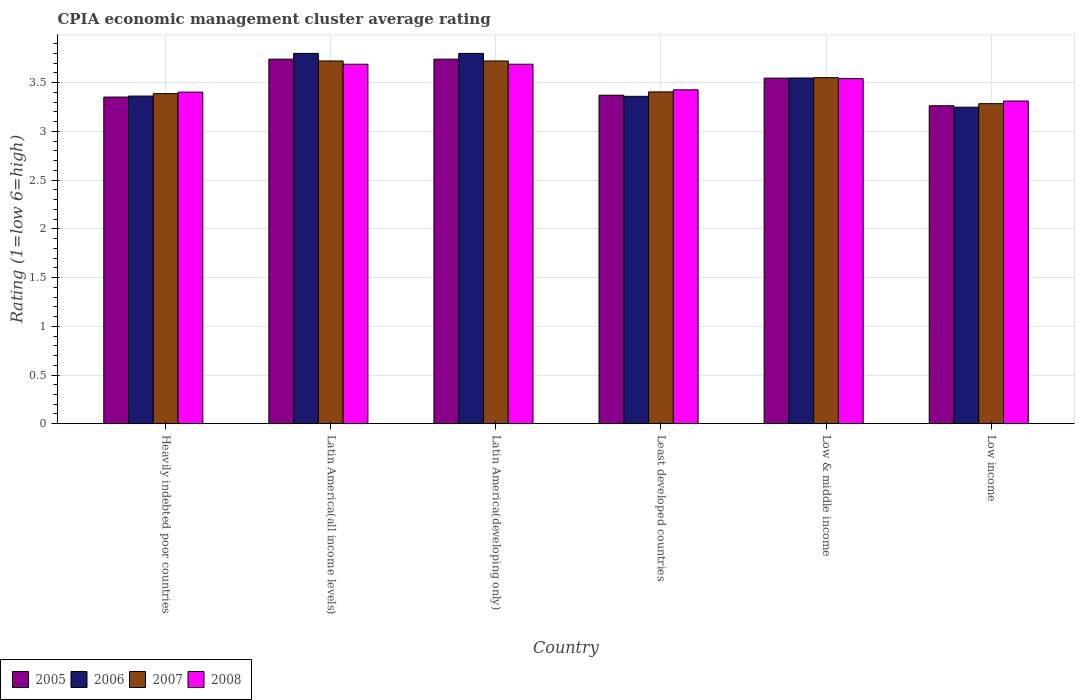Are the number of bars per tick equal to the number of legend labels?
Ensure brevity in your answer.  Yes. Are the number of bars on each tick of the X-axis equal?
Your answer should be compact. Yes. What is the label of the 6th group of bars from the left?
Keep it short and to the point. Low income. In how many cases, is the number of bars for a given country not equal to the number of legend labels?
Offer a terse response. 0. What is the CPIA rating in 2005 in Heavily indebted poor countries?
Provide a succinct answer. 3.35. Across all countries, what is the maximum CPIA rating in 2007?
Offer a terse response. 3.72. Across all countries, what is the minimum CPIA rating in 2005?
Offer a very short reply. 3.26. In which country was the CPIA rating in 2008 maximum?
Your answer should be very brief. Latin America(all income levels). In which country was the CPIA rating in 2008 minimum?
Provide a succinct answer. Low income. What is the total CPIA rating in 2005 in the graph?
Offer a terse response. 21.01. What is the difference between the CPIA rating in 2008 in Latin America(developing only) and that in Low & middle income?
Give a very brief answer. 0.15. What is the difference between the CPIA rating in 2006 in Low & middle income and the CPIA rating in 2007 in Low income?
Provide a short and direct response. 0.26. What is the average CPIA rating in 2006 per country?
Your answer should be very brief. 3.52. What is the difference between the CPIA rating of/in 2005 and CPIA rating of/in 2007 in Low & middle income?
Ensure brevity in your answer.  -0.01. What is the ratio of the CPIA rating in 2006 in Latin America(all income levels) to that in Low & middle income?
Your answer should be compact. 1.07. What is the difference between the highest and the second highest CPIA rating in 2006?
Give a very brief answer. -0.25. What is the difference between the highest and the lowest CPIA rating in 2008?
Your answer should be very brief. 0.38. Is the sum of the CPIA rating in 2008 in Heavily indebted poor countries and Low income greater than the maximum CPIA rating in 2007 across all countries?
Your answer should be compact. Yes. Is it the case that in every country, the sum of the CPIA rating in 2006 and CPIA rating in 2007 is greater than the sum of CPIA rating in 2008 and CPIA rating in 2005?
Provide a short and direct response. No. What does the 1st bar from the right in Heavily indebted poor countries represents?
Offer a very short reply. 2008. Is it the case that in every country, the sum of the CPIA rating in 2006 and CPIA rating in 2005 is greater than the CPIA rating in 2008?
Provide a succinct answer. Yes. Does the graph contain any zero values?
Make the answer very short. No. Where does the legend appear in the graph?
Make the answer very short. Bottom left. How many legend labels are there?
Make the answer very short. 4. How are the legend labels stacked?
Your answer should be compact. Horizontal. What is the title of the graph?
Offer a very short reply. CPIA economic management cluster average rating. Does "1990" appear as one of the legend labels in the graph?
Ensure brevity in your answer.  No. What is the label or title of the Y-axis?
Offer a very short reply. Rating (1=low 6=high). What is the Rating (1=low 6=high) of 2005 in Heavily indebted poor countries?
Your answer should be compact. 3.35. What is the Rating (1=low 6=high) of 2006 in Heavily indebted poor countries?
Provide a succinct answer. 3.36. What is the Rating (1=low 6=high) in 2007 in Heavily indebted poor countries?
Keep it short and to the point. 3.39. What is the Rating (1=low 6=high) of 2008 in Heavily indebted poor countries?
Your answer should be very brief. 3.4. What is the Rating (1=low 6=high) in 2005 in Latin America(all income levels)?
Make the answer very short. 3.74. What is the Rating (1=low 6=high) of 2006 in Latin America(all income levels)?
Offer a very short reply. 3.8. What is the Rating (1=low 6=high) of 2007 in Latin America(all income levels)?
Your response must be concise. 3.72. What is the Rating (1=low 6=high) in 2008 in Latin America(all income levels)?
Keep it short and to the point. 3.69. What is the Rating (1=low 6=high) in 2005 in Latin America(developing only)?
Offer a terse response. 3.74. What is the Rating (1=low 6=high) in 2007 in Latin America(developing only)?
Keep it short and to the point. 3.72. What is the Rating (1=low 6=high) in 2008 in Latin America(developing only)?
Your answer should be compact. 3.69. What is the Rating (1=low 6=high) in 2005 in Least developed countries?
Make the answer very short. 3.37. What is the Rating (1=low 6=high) in 2006 in Least developed countries?
Make the answer very short. 3.36. What is the Rating (1=low 6=high) of 2007 in Least developed countries?
Your answer should be compact. 3.4. What is the Rating (1=low 6=high) in 2008 in Least developed countries?
Ensure brevity in your answer.  3.43. What is the Rating (1=low 6=high) of 2005 in Low & middle income?
Keep it short and to the point. 3.55. What is the Rating (1=low 6=high) of 2006 in Low & middle income?
Provide a succinct answer. 3.55. What is the Rating (1=low 6=high) in 2007 in Low & middle income?
Keep it short and to the point. 3.55. What is the Rating (1=low 6=high) of 2008 in Low & middle income?
Offer a terse response. 3.54. What is the Rating (1=low 6=high) in 2005 in Low income?
Make the answer very short. 3.26. What is the Rating (1=low 6=high) in 2006 in Low income?
Ensure brevity in your answer.  3.25. What is the Rating (1=low 6=high) of 2007 in Low income?
Ensure brevity in your answer.  3.28. What is the Rating (1=low 6=high) in 2008 in Low income?
Offer a very short reply. 3.31. Across all countries, what is the maximum Rating (1=low 6=high) in 2005?
Ensure brevity in your answer.  3.74. Across all countries, what is the maximum Rating (1=low 6=high) of 2007?
Make the answer very short. 3.72. Across all countries, what is the maximum Rating (1=low 6=high) in 2008?
Offer a very short reply. 3.69. Across all countries, what is the minimum Rating (1=low 6=high) in 2005?
Provide a short and direct response. 3.26. Across all countries, what is the minimum Rating (1=low 6=high) in 2006?
Provide a succinct answer. 3.25. Across all countries, what is the minimum Rating (1=low 6=high) of 2007?
Offer a very short reply. 3.28. Across all countries, what is the minimum Rating (1=low 6=high) of 2008?
Provide a short and direct response. 3.31. What is the total Rating (1=low 6=high) in 2005 in the graph?
Give a very brief answer. 21.01. What is the total Rating (1=low 6=high) in 2006 in the graph?
Keep it short and to the point. 21.12. What is the total Rating (1=low 6=high) of 2007 in the graph?
Offer a very short reply. 21.07. What is the total Rating (1=low 6=high) in 2008 in the graph?
Offer a very short reply. 21.06. What is the difference between the Rating (1=low 6=high) of 2005 in Heavily indebted poor countries and that in Latin America(all income levels)?
Provide a short and direct response. -0.39. What is the difference between the Rating (1=low 6=high) of 2006 in Heavily indebted poor countries and that in Latin America(all income levels)?
Keep it short and to the point. -0.44. What is the difference between the Rating (1=low 6=high) in 2007 in Heavily indebted poor countries and that in Latin America(all income levels)?
Offer a terse response. -0.33. What is the difference between the Rating (1=low 6=high) of 2008 in Heavily indebted poor countries and that in Latin America(all income levels)?
Make the answer very short. -0.29. What is the difference between the Rating (1=low 6=high) in 2005 in Heavily indebted poor countries and that in Latin America(developing only)?
Your response must be concise. -0.39. What is the difference between the Rating (1=low 6=high) of 2006 in Heavily indebted poor countries and that in Latin America(developing only)?
Your answer should be compact. -0.44. What is the difference between the Rating (1=low 6=high) in 2007 in Heavily indebted poor countries and that in Latin America(developing only)?
Your response must be concise. -0.33. What is the difference between the Rating (1=low 6=high) of 2008 in Heavily indebted poor countries and that in Latin America(developing only)?
Provide a short and direct response. -0.29. What is the difference between the Rating (1=low 6=high) of 2005 in Heavily indebted poor countries and that in Least developed countries?
Offer a terse response. -0.02. What is the difference between the Rating (1=low 6=high) in 2006 in Heavily indebted poor countries and that in Least developed countries?
Your answer should be very brief. 0. What is the difference between the Rating (1=low 6=high) in 2007 in Heavily indebted poor countries and that in Least developed countries?
Give a very brief answer. -0.02. What is the difference between the Rating (1=low 6=high) in 2008 in Heavily indebted poor countries and that in Least developed countries?
Keep it short and to the point. -0.02. What is the difference between the Rating (1=low 6=high) in 2005 in Heavily indebted poor countries and that in Low & middle income?
Your response must be concise. -0.19. What is the difference between the Rating (1=low 6=high) of 2006 in Heavily indebted poor countries and that in Low & middle income?
Provide a short and direct response. -0.19. What is the difference between the Rating (1=low 6=high) in 2007 in Heavily indebted poor countries and that in Low & middle income?
Your answer should be very brief. -0.16. What is the difference between the Rating (1=low 6=high) in 2008 in Heavily indebted poor countries and that in Low & middle income?
Your answer should be compact. -0.14. What is the difference between the Rating (1=low 6=high) of 2005 in Heavily indebted poor countries and that in Low income?
Offer a very short reply. 0.09. What is the difference between the Rating (1=low 6=high) of 2006 in Heavily indebted poor countries and that in Low income?
Offer a very short reply. 0.11. What is the difference between the Rating (1=low 6=high) in 2007 in Heavily indebted poor countries and that in Low income?
Your answer should be compact. 0.1. What is the difference between the Rating (1=low 6=high) in 2008 in Heavily indebted poor countries and that in Low income?
Offer a terse response. 0.09. What is the difference between the Rating (1=low 6=high) in 2006 in Latin America(all income levels) and that in Latin America(developing only)?
Ensure brevity in your answer.  0. What is the difference between the Rating (1=low 6=high) of 2007 in Latin America(all income levels) and that in Latin America(developing only)?
Offer a very short reply. 0. What is the difference between the Rating (1=low 6=high) in 2008 in Latin America(all income levels) and that in Latin America(developing only)?
Provide a short and direct response. 0. What is the difference between the Rating (1=low 6=high) of 2005 in Latin America(all income levels) and that in Least developed countries?
Your response must be concise. 0.37. What is the difference between the Rating (1=low 6=high) of 2006 in Latin America(all income levels) and that in Least developed countries?
Offer a very short reply. 0.44. What is the difference between the Rating (1=low 6=high) in 2007 in Latin America(all income levels) and that in Least developed countries?
Make the answer very short. 0.32. What is the difference between the Rating (1=low 6=high) in 2008 in Latin America(all income levels) and that in Least developed countries?
Your answer should be very brief. 0.26. What is the difference between the Rating (1=low 6=high) of 2005 in Latin America(all income levels) and that in Low & middle income?
Your answer should be very brief. 0.19. What is the difference between the Rating (1=low 6=high) in 2006 in Latin America(all income levels) and that in Low & middle income?
Give a very brief answer. 0.25. What is the difference between the Rating (1=low 6=high) of 2007 in Latin America(all income levels) and that in Low & middle income?
Ensure brevity in your answer.  0.17. What is the difference between the Rating (1=low 6=high) of 2008 in Latin America(all income levels) and that in Low & middle income?
Your answer should be compact. 0.15. What is the difference between the Rating (1=low 6=high) of 2005 in Latin America(all income levels) and that in Low income?
Offer a very short reply. 0.48. What is the difference between the Rating (1=low 6=high) of 2006 in Latin America(all income levels) and that in Low income?
Give a very brief answer. 0.55. What is the difference between the Rating (1=low 6=high) of 2007 in Latin America(all income levels) and that in Low income?
Offer a terse response. 0.44. What is the difference between the Rating (1=low 6=high) in 2008 in Latin America(all income levels) and that in Low income?
Make the answer very short. 0.38. What is the difference between the Rating (1=low 6=high) of 2005 in Latin America(developing only) and that in Least developed countries?
Offer a terse response. 0.37. What is the difference between the Rating (1=low 6=high) in 2006 in Latin America(developing only) and that in Least developed countries?
Ensure brevity in your answer.  0.44. What is the difference between the Rating (1=low 6=high) of 2007 in Latin America(developing only) and that in Least developed countries?
Offer a terse response. 0.32. What is the difference between the Rating (1=low 6=high) in 2008 in Latin America(developing only) and that in Least developed countries?
Offer a terse response. 0.26. What is the difference between the Rating (1=low 6=high) of 2005 in Latin America(developing only) and that in Low & middle income?
Your answer should be compact. 0.19. What is the difference between the Rating (1=low 6=high) in 2006 in Latin America(developing only) and that in Low & middle income?
Offer a terse response. 0.25. What is the difference between the Rating (1=low 6=high) in 2007 in Latin America(developing only) and that in Low & middle income?
Provide a succinct answer. 0.17. What is the difference between the Rating (1=low 6=high) of 2008 in Latin America(developing only) and that in Low & middle income?
Your answer should be very brief. 0.15. What is the difference between the Rating (1=low 6=high) of 2005 in Latin America(developing only) and that in Low income?
Give a very brief answer. 0.48. What is the difference between the Rating (1=low 6=high) in 2006 in Latin America(developing only) and that in Low income?
Keep it short and to the point. 0.55. What is the difference between the Rating (1=low 6=high) in 2007 in Latin America(developing only) and that in Low income?
Keep it short and to the point. 0.44. What is the difference between the Rating (1=low 6=high) in 2008 in Latin America(developing only) and that in Low income?
Make the answer very short. 0.38. What is the difference between the Rating (1=low 6=high) in 2005 in Least developed countries and that in Low & middle income?
Provide a short and direct response. -0.18. What is the difference between the Rating (1=low 6=high) in 2006 in Least developed countries and that in Low & middle income?
Give a very brief answer. -0.19. What is the difference between the Rating (1=low 6=high) of 2007 in Least developed countries and that in Low & middle income?
Provide a succinct answer. -0.15. What is the difference between the Rating (1=low 6=high) of 2008 in Least developed countries and that in Low & middle income?
Provide a short and direct response. -0.12. What is the difference between the Rating (1=low 6=high) of 2005 in Least developed countries and that in Low income?
Give a very brief answer. 0.11. What is the difference between the Rating (1=low 6=high) of 2006 in Least developed countries and that in Low income?
Make the answer very short. 0.11. What is the difference between the Rating (1=low 6=high) of 2007 in Least developed countries and that in Low income?
Your response must be concise. 0.12. What is the difference between the Rating (1=low 6=high) of 2008 in Least developed countries and that in Low income?
Ensure brevity in your answer.  0.12. What is the difference between the Rating (1=low 6=high) of 2005 in Low & middle income and that in Low income?
Give a very brief answer. 0.28. What is the difference between the Rating (1=low 6=high) of 2006 in Low & middle income and that in Low income?
Keep it short and to the point. 0.3. What is the difference between the Rating (1=low 6=high) of 2007 in Low & middle income and that in Low income?
Make the answer very short. 0.27. What is the difference between the Rating (1=low 6=high) of 2008 in Low & middle income and that in Low income?
Offer a very short reply. 0.23. What is the difference between the Rating (1=low 6=high) of 2005 in Heavily indebted poor countries and the Rating (1=low 6=high) of 2006 in Latin America(all income levels)?
Provide a short and direct response. -0.45. What is the difference between the Rating (1=low 6=high) of 2005 in Heavily indebted poor countries and the Rating (1=low 6=high) of 2007 in Latin America(all income levels)?
Your response must be concise. -0.37. What is the difference between the Rating (1=low 6=high) in 2005 in Heavily indebted poor countries and the Rating (1=low 6=high) in 2008 in Latin America(all income levels)?
Your answer should be very brief. -0.34. What is the difference between the Rating (1=low 6=high) in 2006 in Heavily indebted poor countries and the Rating (1=low 6=high) in 2007 in Latin America(all income levels)?
Your response must be concise. -0.36. What is the difference between the Rating (1=low 6=high) of 2006 in Heavily indebted poor countries and the Rating (1=low 6=high) of 2008 in Latin America(all income levels)?
Make the answer very short. -0.33. What is the difference between the Rating (1=low 6=high) of 2007 in Heavily indebted poor countries and the Rating (1=low 6=high) of 2008 in Latin America(all income levels)?
Provide a short and direct response. -0.3. What is the difference between the Rating (1=low 6=high) of 2005 in Heavily indebted poor countries and the Rating (1=low 6=high) of 2006 in Latin America(developing only)?
Provide a succinct answer. -0.45. What is the difference between the Rating (1=low 6=high) of 2005 in Heavily indebted poor countries and the Rating (1=low 6=high) of 2007 in Latin America(developing only)?
Your answer should be very brief. -0.37. What is the difference between the Rating (1=low 6=high) in 2005 in Heavily indebted poor countries and the Rating (1=low 6=high) in 2008 in Latin America(developing only)?
Offer a very short reply. -0.34. What is the difference between the Rating (1=low 6=high) of 2006 in Heavily indebted poor countries and the Rating (1=low 6=high) of 2007 in Latin America(developing only)?
Keep it short and to the point. -0.36. What is the difference between the Rating (1=low 6=high) in 2006 in Heavily indebted poor countries and the Rating (1=low 6=high) in 2008 in Latin America(developing only)?
Give a very brief answer. -0.33. What is the difference between the Rating (1=low 6=high) of 2007 in Heavily indebted poor countries and the Rating (1=low 6=high) of 2008 in Latin America(developing only)?
Provide a succinct answer. -0.3. What is the difference between the Rating (1=low 6=high) of 2005 in Heavily indebted poor countries and the Rating (1=low 6=high) of 2006 in Least developed countries?
Ensure brevity in your answer.  -0.01. What is the difference between the Rating (1=low 6=high) of 2005 in Heavily indebted poor countries and the Rating (1=low 6=high) of 2007 in Least developed countries?
Offer a very short reply. -0.05. What is the difference between the Rating (1=low 6=high) of 2005 in Heavily indebted poor countries and the Rating (1=low 6=high) of 2008 in Least developed countries?
Your response must be concise. -0.07. What is the difference between the Rating (1=low 6=high) of 2006 in Heavily indebted poor countries and the Rating (1=low 6=high) of 2007 in Least developed countries?
Your answer should be compact. -0.04. What is the difference between the Rating (1=low 6=high) of 2006 in Heavily indebted poor countries and the Rating (1=low 6=high) of 2008 in Least developed countries?
Offer a terse response. -0.06. What is the difference between the Rating (1=low 6=high) of 2007 in Heavily indebted poor countries and the Rating (1=low 6=high) of 2008 in Least developed countries?
Your answer should be very brief. -0.04. What is the difference between the Rating (1=low 6=high) of 2005 in Heavily indebted poor countries and the Rating (1=low 6=high) of 2006 in Low & middle income?
Give a very brief answer. -0.2. What is the difference between the Rating (1=low 6=high) in 2005 in Heavily indebted poor countries and the Rating (1=low 6=high) in 2007 in Low & middle income?
Offer a terse response. -0.2. What is the difference between the Rating (1=low 6=high) in 2005 in Heavily indebted poor countries and the Rating (1=low 6=high) in 2008 in Low & middle income?
Offer a terse response. -0.19. What is the difference between the Rating (1=low 6=high) of 2006 in Heavily indebted poor countries and the Rating (1=low 6=high) of 2007 in Low & middle income?
Make the answer very short. -0.19. What is the difference between the Rating (1=low 6=high) of 2006 in Heavily indebted poor countries and the Rating (1=low 6=high) of 2008 in Low & middle income?
Your response must be concise. -0.18. What is the difference between the Rating (1=low 6=high) in 2007 in Heavily indebted poor countries and the Rating (1=low 6=high) in 2008 in Low & middle income?
Offer a very short reply. -0.15. What is the difference between the Rating (1=low 6=high) of 2005 in Heavily indebted poor countries and the Rating (1=low 6=high) of 2006 in Low income?
Keep it short and to the point. 0.1. What is the difference between the Rating (1=low 6=high) of 2005 in Heavily indebted poor countries and the Rating (1=low 6=high) of 2007 in Low income?
Ensure brevity in your answer.  0.07. What is the difference between the Rating (1=low 6=high) of 2005 in Heavily indebted poor countries and the Rating (1=low 6=high) of 2008 in Low income?
Provide a short and direct response. 0.04. What is the difference between the Rating (1=low 6=high) of 2006 in Heavily indebted poor countries and the Rating (1=low 6=high) of 2007 in Low income?
Offer a very short reply. 0.08. What is the difference between the Rating (1=low 6=high) of 2006 in Heavily indebted poor countries and the Rating (1=low 6=high) of 2008 in Low income?
Your answer should be compact. 0.05. What is the difference between the Rating (1=low 6=high) of 2007 in Heavily indebted poor countries and the Rating (1=low 6=high) of 2008 in Low income?
Offer a very short reply. 0.08. What is the difference between the Rating (1=low 6=high) in 2005 in Latin America(all income levels) and the Rating (1=low 6=high) in 2006 in Latin America(developing only)?
Make the answer very short. -0.06. What is the difference between the Rating (1=low 6=high) of 2005 in Latin America(all income levels) and the Rating (1=low 6=high) of 2007 in Latin America(developing only)?
Give a very brief answer. 0.02. What is the difference between the Rating (1=low 6=high) of 2005 in Latin America(all income levels) and the Rating (1=low 6=high) of 2008 in Latin America(developing only)?
Offer a terse response. 0.05. What is the difference between the Rating (1=low 6=high) in 2006 in Latin America(all income levels) and the Rating (1=low 6=high) in 2007 in Latin America(developing only)?
Your answer should be compact. 0.08. What is the difference between the Rating (1=low 6=high) in 2007 in Latin America(all income levels) and the Rating (1=low 6=high) in 2008 in Latin America(developing only)?
Your answer should be very brief. 0.03. What is the difference between the Rating (1=low 6=high) of 2005 in Latin America(all income levels) and the Rating (1=low 6=high) of 2006 in Least developed countries?
Give a very brief answer. 0.38. What is the difference between the Rating (1=low 6=high) in 2005 in Latin America(all income levels) and the Rating (1=low 6=high) in 2007 in Least developed countries?
Give a very brief answer. 0.34. What is the difference between the Rating (1=low 6=high) in 2005 in Latin America(all income levels) and the Rating (1=low 6=high) in 2008 in Least developed countries?
Your answer should be compact. 0.31. What is the difference between the Rating (1=low 6=high) in 2006 in Latin America(all income levels) and the Rating (1=low 6=high) in 2007 in Least developed countries?
Provide a succinct answer. 0.4. What is the difference between the Rating (1=low 6=high) of 2006 in Latin America(all income levels) and the Rating (1=low 6=high) of 2008 in Least developed countries?
Ensure brevity in your answer.  0.37. What is the difference between the Rating (1=low 6=high) of 2007 in Latin America(all income levels) and the Rating (1=low 6=high) of 2008 in Least developed countries?
Provide a short and direct response. 0.3. What is the difference between the Rating (1=low 6=high) in 2005 in Latin America(all income levels) and the Rating (1=low 6=high) in 2006 in Low & middle income?
Offer a terse response. 0.19. What is the difference between the Rating (1=low 6=high) of 2005 in Latin America(all income levels) and the Rating (1=low 6=high) of 2007 in Low & middle income?
Keep it short and to the point. 0.19. What is the difference between the Rating (1=low 6=high) in 2005 in Latin America(all income levels) and the Rating (1=low 6=high) in 2008 in Low & middle income?
Offer a terse response. 0.2. What is the difference between the Rating (1=low 6=high) in 2006 in Latin America(all income levels) and the Rating (1=low 6=high) in 2007 in Low & middle income?
Provide a succinct answer. 0.25. What is the difference between the Rating (1=low 6=high) of 2006 in Latin America(all income levels) and the Rating (1=low 6=high) of 2008 in Low & middle income?
Give a very brief answer. 0.26. What is the difference between the Rating (1=low 6=high) of 2007 in Latin America(all income levels) and the Rating (1=low 6=high) of 2008 in Low & middle income?
Ensure brevity in your answer.  0.18. What is the difference between the Rating (1=low 6=high) of 2005 in Latin America(all income levels) and the Rating (1=low 6=high) of 2006 in Low income?
Your answer should be very brief. 0.49. What is the difference between the Rating (1=low 6=high) of 2005 in Latin America(all income levels) and the Rating (1=low 6=high) of 2007 in Low income?
Offer a terse response. 0.46. What is the difference between the Rating (1=low 6=high) in 2005 in Latin America(all income levels) and the Rating (1=low 6=high) in 2008 in Low income?
Your answer should be compact. 0.43. What is the difference between the Rating (1=low 6=high) of 2006 in Latin America(all income levels) and the Rating (1=low 6=high) of 2007 in Low income?
Provide a short and direct response. 0.52. What is the difference between the Rating (1=low 6=high) of 2006 in Latin America(all income levels) and the Rating (1=low 6=high) of 2008 in Low income?
Make the answer very short. 0.49. What is the difference between the Rating (1=low 6=high) in 2007 in Latin America(all income levels) and the Rating (1=low 6=high) in 2008 in Low income?
Give a very brief answer. 0.41. What is the difference between the Rating (1=low 6=high) in 2005 in Latin America(developing only) and the Rating (1=low 6=high) in 2006 in Least developed countries?
Offer a very short reply. 0.38. What is the difference between the Rating (1=low 6=high) of 2005 in Latin America(developing only) and the Rating (1=low 6=high) of 2007 in Least developed countries?
Provide a short and direct response. 0.34. What is the difference between the Rating (1=low 6=high) in 2005 in Latin America(developing only) and the Rating (1=low 6=high) in 2008 in Least developed countries?
Offer a very short reply. 0.31. What is the difference between the Rating (1=low 6=high) in 2006 in Latin America(developing only) and the Rating (1=low 6=high) in 2007 in Least developed countries?
Provide a short and direct response. 0.4. What is the difference between the Rating (1=low 6=high) of 2006 in Latin America(developing only) and the Rating (1=low 6=high) of 2008 in Least developed countries?
Keep it short and to the point. 0.37. What is the difference between the Rating (1=low 6=high) in 2007 in Latin America(developing only) and the Rating (1=low 6=high) in 2008 in Least developed countries?
Make the answer very short. 0.3. What is the difference between the Rating (1=low 6=high) of 2005 in Latin America(developing only) and the Rating (1=low 6=high) of 2006 in Low & middle income?
Your answer should be very brief. 0.19. What is the difference between the Rating (1=low 6=high) in 2005 in Latin America(developing only) and the Rating (1=low 6=high) in 2007 in Low & middle income?
Make the answer very short. 0.19. What is the difference between the Rating (1=low 6=high) of 2005 in Latin America(developing only) and the Rating (1=low 6=high) of 2008 in Low & middle income?
Ensure brevity in your answer.  0.2. What is the difference between the Rating (1=low 6=high) of 2006 in Latin America(developing only) and the Rating (1=low 6=high) of 2007 in Low & middle income?
Make the answer very short. 0.25. What is the difference between the Rating (1=low 6=high) in 2006 in Latin America(developing only) and the Rating (1=low 6=high) in 2008 in Low & middle income?
Give a very brief answer. 0.26. What is the difference between the Rating (1=low 6=high) in 2007 in Latin America(developing only) and the Rating (1=low 6=high) in 2008 in Low & middle income?
Your response must be concise. 0.18. What is the difference between the Rating (1=low 6=high) of 2005 in Latin America(developing only) and the Rating (1=low 6=high) of 2006 in Low income?
Provide a short and direct response. 0.49. What is the difference between the Rating (1=low 6=high) of 2005 in Latin America(developing only) and the Rating (1=low 6=high) of 2007 in Low income?
Your answer should be very brief. 0.46. What is the difference between the Rating (1=low 6=high) of 2005 in Latin America(developing only) and the Rating (1=low 6=high) of 2008 in Low income?
Offer a very short reply. 0.43. What is the difference between the Rating (1=low 6=high) of 2006 in Latin America(developing only) and the Rating (1=low 6=high) of 2007 in Low income?
Make the answer very short. 0.52. What is the difference between the Rating (1=low 6=high) in 2006 in Latin America(developing only) and the Rating (1=low 6=high) in 2008 in Low income?
Offer a terse response. 0.49. What is the difference between the Rating (1=low 6=high) of 2007 in Latin America(developing only) and the Rating (1=low 6=high) of 2008 in Low income?
Your answer should be compact. 0.41. What is the difference between the Rating (1=low 6=high) of 2005 in Least developed countries and the Rating (1=low 6=high) of 2006 in Low & middle income?
Your answer should be compact. -0.18. What is the difference between the Rating (1=low 6=high) in 2005 in Least developed countries and the Rating (1=low 6=high) in 2007 in Low & middle income?
Your answer should be compact. -0.18. What is the difference between the Rating (1=low 6=high) of 2005 in Least developed countries and the Rating (1=low 6=high) of 2008 in Low & middle income?
Keep it short and to the point. -0.17. What is the difference between the Rating (1=low 6=high) in 2006 in Least developed countries and the Rating (1=low 6=high) in 2007 in Low & middle income?
Make the answer very short. -0.19. What is the difference between the Rating (1=low 6=high) in 2006 in Least developed countries and the Rating (1=low 6=high) in 2008 in Low & middle income?
Give a very brief answer. -0.18. What is the difference between the Rating (1=low 6=high) in 2007 in Least developed countries and the Rating (1=low 6=high) in 2008 in Low & middle income?
Offer a very short reply. -0.14. What is the difference between the Rating (1=low 6=high) of 2005 in Least developed countries and the Rating (1=low 6=high) of 2006 in Low income?
Make the answer very short. 0.12. What is the difference between the Rating (1=low 6=high) of 2005 in Least developed countries and the Rating (1=low 6=high) of 2007 in Low income?
Provide a succinct answer. 0.09. What is the difference between the Rating (1=low 6=high) in 2005 in Least developed countries and the Rating (1=low 6=high) in 2008 in Low income?
Provide a succinct answer. 0.06. What is the difference between the Rating (1=low 6=high) in 2006 in Least developed countries and the Rating (1=low 6=high) in 2007 in Low income?
Keep it short and to the point. 0.08. What is the difference between the Rating (1=low 6=high) of 2006 in Least developed countries and the Rating (1=low 6=high) of 2008 in Low income?
Your answer should be very brief. 0.05. What is the difference between the Rating (1=low 6=high) in 2007 in Least developed countries and the Rating (1=low 6=high) in 2008 in Low income?
Your answer should be very brief. 0.09. What is the difference between the Rating (1=low 6=high) of 2005 in Low & middle income and the Rating (1=low 6=high) of 2006 in Low income?
Keep it short and to the point. 0.3. What is the difference between the Rating (1=low 6=high) of 2005 in Low & middle income and the Rating (1=low 6=high) of 2007 in Low income?
Give a very brief answer. 0.26. What is the difference between the Rating (1=low 6=high) in 2005 in Low & middle income and the Rating (1=low 6=high) in 2008 in Low income?
Offer a terse response. 0.23. What is the difference between the Rating (1=low 6=high) of 2006 in Low & middle income and the Rating (1=low 6=high) of 2007 in Low income?
Make the answer very short. 0.26. What is the difference between the Rating (1=low 6=high) in 2006 in Low & middle income and the Rating (1=low 6=high) in 2008 in Low income?
Provide a succinct answer. 0.24. What is the difference between the Rating (1=low 6=high) of 2007 in Low & middle income and the Rating (1=low 6=high) of 2008 in Low income?
Make the answer very short. 0.24. What is the average Rating (1=low 6=high) in 2005 per country?
Give a very brief answer. 3.5. What is the average Rating (1=low 6=high) in 2006 per country?
Provide a succinct answer. 3.52. What is the average Rating (1=low 6=high) in 2007 per country?
Offer a very short reply. 3.51. What is the average Rating (1=low 6=high) in 2008 per country?
Keep it short and to the point. 3.51. What is the difference between the Rating (1=low 6=high) in 2005 and Rating (1=low 6=high) in 2006 in Heavily indebted poor countries?
Give a very brief answer. -0.01. What is the difference between the Rating (1=low 6=high) in 2005 and Rating (1=low 6=high) in 2007 in Heavily indebted poor countries?
Keep it short and to the point. -0.04. What is the difference between the Rating (1=low 6=high) of 2005 and Rating (1=low 6=high) of 2008 in Heavily indebted poor countries?
Provide a succinct answer. -0.05. What is the difference between the Rating (1=low 6=high) in 2006 and Rating (1=low 6=high) in 2007 in Heavily indebted poor countries?
Give a very brief answer. -0.03. What is the difference between the Rating (1=low 6=high) in 2006 and Rating (1=low 6=high) in 2008 in Heavily indebted poor countries?
Make the answer very short. -0.04. What is the difference between the Rating (1=low 6=high) in 2007 and Rating (1=low 6=high) in 2008 in Heavily indebted poor countries?
Your answer should be compact. -0.02. What is the difference between the Rating (1=low 6=high) of 2005 and Rating (1=low 6=high) of 2006 in Latin America(all income levels)?
Make the answer very short. -0.06. What is the difference between the Rating (1=low 6=high) in 2005 and Rating (1=low 6=high) in 2007 in Latin America(all income levels)?
Offer a terse response. 0.02. What is the difference between the Rating (1=low 6=high) of 2005 and Rating (1=low 6=high) of 2008 in Latin America(all income levels)?
Offer a terse response. 0.05. What is the difference between the Rating (1=low 6=high) of 2006 and Rating (1=low 6=high) of 2007 in Latin America(all income levels)?
Give a very brief answer. 0.08. What is the difference between the Rating (1=low 6=high) of 2006 and Rating (1=low 6=high) of 2008 in Latin America(all income levels)?
Keep it short and to the point. 0.11. What is the difference between the Rating (1=low 6=high) in 2005 and Rating (1=low 6=high) in 2006 in Latin America(developing only)?
Provide a succinct answer. -0.06. What is the difference between the Rating (1=low 6=high) of 2005 and Rating (1=low 6=high) of 2007 in Latin America(developing only)?
Offer a very short reply. 0.02. What is the difference between the Rating (1=low 6=high) of 2005 and Rating (1=low 6=high) of 2008 in Latin America(developing only)?
Keep it short and to the point. 0.05. What is the difference between the Rating (1=low 6=high) in 2006 and Rating (1=low 6=high) in 2007 in Latin America(developing only)?
Your answer should be very brief. 0.08. What is the difference between the Rating (1=low 6=high) in 2006 and Rating (1=low 6=high) in 2008 in Latin America(developing only)?
Make the answer very short. 0.11. What is the difference between the Rating (1=low 6=high) of 2007 and Rating (1=low 6=high) of 2008 in Latin America(developing only)?
Your response must be concise. 0.03. What is the difference between the Rating (1=low 6=high) of 2005 and Rating (1=low 6=high) of 2006 in Least developed countries?
Give a very brief answer. 0.01. What is the difference between the Rating (1=low 6=high) in 2005 and Rating (1=low 6=high) in 2007 in Least developed countries?
Your answer should be compact. -0.03. What is the difference between the Rating (1=low 6=high) in 2005 and Rating (1=low 6=high) in 2008 in Least developed countries?
Your response must be concise. -0.06. What is the difference between the Rating (1=low 6=high) of 2006 and Rating (1=low 6=high) of 2007 in Least developed countries?
Your answer should be very brief. -0.05. What is the difference between the Rating (1=low 6=high) in 2006 and Rating (1=low 6=high) in 2008 in Least developed countries?
Keep it short and to the point. -0.07. What is the difference between the Rating (1=low 6=high) in 2007 and Rating (1=low 6=high) in 2008 in Least developed countries?
Ensure brevity in your answer.  -0.02. What is the difference between the Rating (1=low 6=high) in 2005 and Rating (1=low 6=high) in 2006 in Low & middle income?
Your response must be concise. -0. What is the difference between the Rating (1=low 6=high) in 2005 and Rating (1=low 6=high) in 2007 in Low & middle income?
Offer a very short reply. -0.01. What is the difference between the Rating (1=low 6=high) in 2005 and Rating (1=low 6=high) in 2008 in Low & middle income?
Ensure brevity in your answer.  0. What is the difference between the Rating (1=low 6=high) in 2006 and Rating (1=low 6=high) in 2007 in Low & middle income?
Your answer should be compact. -0. What is the difference between the Rating (1=low 6=high) of 2006 and Rating (1=low 6=high) of 2008 in Low & middle income?
Your answer should be very brief. 0.01. What is the difference between the Rating (1=low 6=high) in 2007 and Rating (1=low 6=high) in 2008 in Low & middle income?
Give a very brief answer. 0.01. What is the difference between the Rating (1=low 6=high) of 2005 and Rating (1=low 6=high) of 2006 in Low income?
Offer a terse response. 0.01. What is the difference between the Rating (1=low 6=high) in 2005 and Rating (1=low 6=high) in 2007 in Low income?
Provide a short and direct response. -0.02. What is the difference between the Rating (1=low 6=high) of 2005 and Rating (1=low 6=high) of 2008 in Low income?
Keep it short and to the point. -0.05. What is the difference between the Rating (1=low 6=high) of 2006 and Rating (1=low 6=high) of 2007 in Low income?
Provide a short and direct response. -0.04. What is the difference between the Rating (1=low 6=high) of 2006 and Rating (1=low 6=high) of 2008 in Low income?
Your response must be concise. -0.06. What is the difference between the Rating (1=low 6=high) of 2007 and Rating (1=low 6=high) of 2008 in Low income?
Make the answer very short. -0.03. What is the ratio of the Rating (1=low 6=high) of 2005 in Heavily indebted poor countries to that in Latin America(all income levels)?
Give a very brief answer. 0.9. What is the ratio of the Rating (1=low 6=high) in 2006 in Heavily indebted poor countries to that in Latin America(all income levels)?
Offer a very short reply. 0.88. What is the ratio of the Rating (1=low 6=high) of 2007 in Heavily indebted poor countries to that in Latin America(all income levels)?
Offer a very short reply. 0.91. What is the ratio of the Rating (1=low 6=high) of 2008 in Heavily indebted poor countries to that in Latin America(all income levels)?
Offer a very short reply. 0.92. What is the ratio of the Rating (1=low 6=high) of 2005 in Heavily indebted poor countries to that in Latin America(developing only)?
Your answer should be very brief. 0.9. What is the ratio of the Rating (1=low 6=high) in 2006 in Heavily indebted poor countries to that in Latin America(developing only)?
Offer a very short reply. 0.88. What is the ratio of the Rating (1=low 6=high) in 2007 in Heavily indebted poor countries to that in Latin America(developing only)?
Offer a terse response. 0.91. What is the ratio of the Rating (1=low 6=high) in 2008 in Heavily indebted poor countries to that in Latin America(developing only)?
Make the answer very short. 0.92. What is the ratio of the Rating (1=low 6=high) in 2008 in Heavily indebted poor countries to that in Least developed countries?
Ensure brevity in your answer.  0.99. What is the ratio of the Rating (1=low 6=high) in 2005 in Heavily indebted poor countries to that in Low & middle income?
Make the answer very short. 0.95. What is the ratio of the Rating (1=low 6=high) of 2006 in Heavily indebted poor countries to that in Low & middle income?
Offer a terse response. 0.95. What is the ratio of the Rating (1=low 6=high) of 2007 in Heavily indebted poor countries to that in Low & middle income?
Your answer should be very brief. 0.95. What is the ratio of the Rating (1=low 6=high) in 2008 in Heavily indebted poor countries to that in Low & middle income?
Make the answer very short. 0.96. What is the ratio of the Rating (1=low 6=high) in 2005 in Heavily indebted poor countries to that in Low income?
Provide a short and direct response. 1.03. What is the ratio of the Rating (1=low 6=high) of 2006 in Heavily indebted poor countries to that in Low income?
Your answer should be very brief. 1.04. What is the ratio of the Rating (1=low 6=high) in 2007 in Heavily indebted poor countries to that in Low income?
Your response must be concise. 1.03. What is the ratio of the Rating (1=low 6=high) in 2008 in Heavily indebted poor countries to that in Low income?
Offer a terse response. 1.03. What is the ratio of the Rating (1=low 6=high) of 2007 in Latin America(all income levels) to that in Latin America(developing only)?
Your response must be concise. 1. What is the ratio of the Rating (1=low 6=high) in 2008 in Latin America(all income levels) to that in Latin America(developing only)?
Provide a succinct answer. 1. What is the ratio of the Rating (1=low 6=high) in 2005 in Latin America(all income levels) to that in Least developed countries?
Keep it short and to the point. 1.11. What is the ratio of the Rating (1=low 6=high) of 2006 in Latin America(all income levels) to that in Least developed countries?
Make the answer very short. 1.13. What is the ratio of the Rating (1=low 6=high) in 2007 in Latin America(all income levels) to that in Least developed countries?
Give a very brief answer. 1.09. What is the ratio of the Rating (1=low 6=high) in 2008 in Latin America(all income levels) to that in Least developed countries?
Make the answer very short. 1.08. What is the ratio of the Rating (1=low 6=high) of 2005 in Latin America(all income levels) to that in Low & middle income?
Offer a very short reply. 1.05. What is the ratio of the Rating (1=low 6=high) of 2006 in Latin America(all income levels) to that in Low & middle income?
Offer a very short reply. 1.07. What is the ratio of the Rating (1=low 6=high) of 2007 in Latin America(all income levels) to that in Low & middle income?
Give a very brief answer. 1.05. What is the ratio of the Rating (1=low 6=high) of 2008 in Latin America(all income levels) to that in Low & middle income?
Your response must be concise. 1.04. What is the ratio of the Rating (1=low 6=high) in 2005 in Latin America(all income levels) to that in Low income?
Give a very brief answer. 1.15. What is the ratio of the Rating (1=low 6=high) of 2006 in Latin America(all income levels) to that in Low income?
Offer a very short reply. 1.17. What is the ratio of the Rating (1=low 6=high) in 2007 in Latin America(all income levels) to that in Low income?
Offer a terse response. 1.13. What is the ratio of the Rating (1=low 6=high) of 2008 in Latin America(all income levels) to that in Low income?
Your answer should be compact. 1.11. What is the ratio of the Rating (1=low 6=high) in 2005 in Latin America(developing only) to that in Least developed countries?
Give a very brief answer. 1.11. What is the ratio of the Rating (1=low 6=high) of 2006 in Latin America(developing only) to that in Least developed countries?
Provide a short and direct response. 1.13. What is the ratio of the Rating (1=low 6=high) in 2007 in Latin America(developing only) to that in Least developed countries?
Offer a very short reply. 1.09. What is the ratio of the Rating (1=low 6=high) in 2008 in Latin America(developing only) to that in Least developed countries?
Your answer should be very brief. 1.08. What is the ratio of the Rating (1=low 6=high) of 2005 in Latin America(developing only) to that in Low & middle income?
Ensure brevity in your answer.  1.05. What is the ratio of the Rating (1=low 6=high) of 2006 in Latin America(developing only) to that in Low & middle income?
Your answer should be compact. 1.07. What is the ratio of the Rating (1=low 6=high) of 2007 in Latin America(developing only) to that in Low & middle income?
Your answer should be very brief. 1.05. What is the ratio of the Rating (1=low 6=high) in 2008 in Latin America(developing only) to that in Low & middle income?
Provide a succinct answer. 1.04. What is the ratio of the Rating (1=low 6=high) of 2005 in Latin America(developing only) to that in Low income?
Your answer should be very brief. 1.15. What is the ratio of the Rating (1=low 6=high) of 2006 in Latin America(developing only) to that in Low income?
Offer a terse response. 1.17. What is the ratio of the Rating (1=low 6=high) of 2007 in Latin America(developing only) to that in Low income?
Offer a terse response. 1.13. What is the ratio of the Rating (1=low 6=high) of 2008 in Latin America(developing only) to that in Low income?
Provide a short and direct response. 1.11. What is the ratio of the Rating (1=low 6=high) of 2005 in Least developed countries to that in Low & middle income?
Keep it short and to the point. 0.95. What is the ratio of the Rating (1=low 6=high) in 2006 in Least developed countries to that in Low & middle income?
Offer a very short reply. 0.95. What is the ratio of the Rating (1=low 6=high) of 2007 in Least developed countries to that in Low & middle income?
Provide a short and direct response. 0.96. What is the ratio of the Rating (1=low 6=high) in 2008 in Least developed countries to that in Low & middle income?
Your response must be concise. 0.97. What is the ratio of the Rating (1=low 6=high) of 2005 in Least developed countries to that in Low income?
Keep it short and to the point. 1.03. What is the ratio of the Rating (1=low 6=high) in 2006 in Least developed countries to that in Low income?
Keep it short and to the point. 1.03. What is the ratio of the Rating (1=low 6=high) of 2007 in Least developed countries to that in Low income?
Make the answer very short. 1.04. What is the ratio of the Rating (1=low 6=high) of 2008 in Least developed countries to that in Low income?
Your answer should be very brief. 1.03. What is the ratio of the Rating (1=low 6=high) in 2005 in Low & middle income to that in Low income?
Make the answer very short. 1.09. What is the ratio of the Rating (1=low 6=high) in 2006 in Low & middle income to that in Low income?
Give a very brief answer. 1.09. What is the ratio of the Rating (1=low 6=high) of 2007 in Low & middle income to that in Low income?
Keep it short and to the point. 1.08. What is the ratio of the Rating (1=low 6=high) in 2008 in Low & middle income to that in Low income?
Your answer should be compact. 1.07. What is the difference between the highest and the second highest Rating (1=low 6=high) in 2006?
Offer a very short reply. 0. What is the difference between the highest and the lowest Rating (1=low 6=high) in 2005?
Provide a short and direct response. 0.48. What is the difference between the highest and the lowest Rating (1=low 6=high) in 2006?
Provide a succinct answer. 0.55. What is the difference between the highest and the lowest Rating (1=low 6=high) in 2007?
Make the answer very short. 0.44. What is the difference between the highest and the lowest Rating (1=low 6=high) in 2008?
Ensure brevity in your answer.  0.38. 